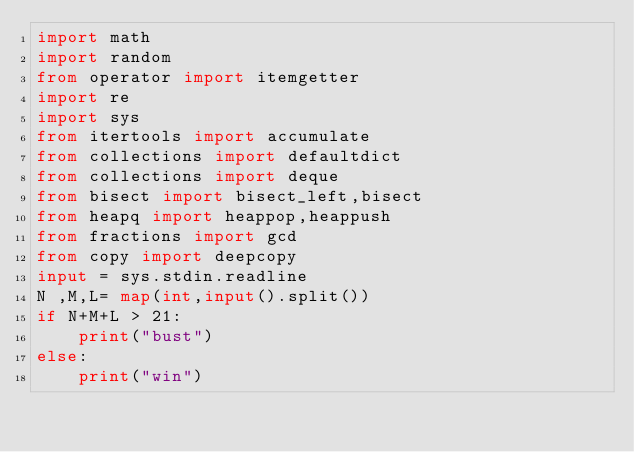Convert code to text. <code><loc_0><loc_0><loc_500><loc_500><_Python_>import math
import random
from operator import itemgetter
import re
import sys
from itertools import accumulate
from collections import defaultdict
from collections import deque
from bisect import bisect_left,bisect
from heapq import heappop,heappush
from fractions import gcd
from copy import deepcopy
input = sys.stdin.readline
N ,M,L= map(int,input().split())
if N+M+L > 21:
    print("bust")
else:
    print("win")</code> 